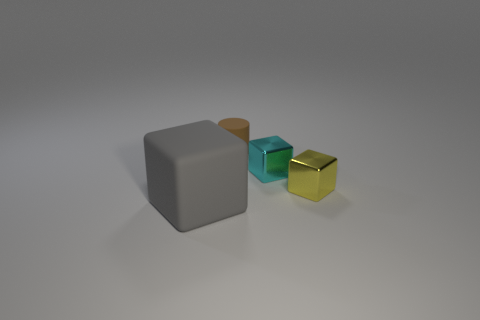Does the yellow object have the same shape as the small cyan object?
Ensure brevity in your answer.  Yes. Are there the same number of blocks that are in front of the big gray matte thing and small cyan objects that are behind the brown cylinder?
Your answer should be very brief. Yes. There is a big thing that is the same material as the tiny brown cylinder; what color is it?
Make the answer very short. Gray. What number of brown cylinders have the same material as the big object?
Your answer should be compact. 1. There is a matte object that is in front of the small matte cylinder; is its color the same as the matte cylinder?
Keep it short and to the point. No. How many big things are the same shape as the small cyan object?
Ensure brevity in your answer.  1. Are there an equal number of brown objects in front of the large thing and rubber cylinders?
Offer a very short reply. No. There is a matte cylinder that is the same size as the cyan metal thing; what is its color?
Your answer should be very brief. Brown. Is there a big green metallic thing that has the same shape as the brown thing?
Provide a succinct answer. No. What material is the object that is left of the rubber object right of the rubber object that is to the left of the brown object?
Offer a terse response. Rubber. 